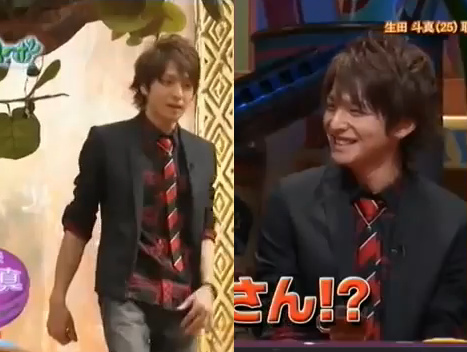Is the man that is walking wearing a cap? No, the man who is walking is not wearing a cap. 